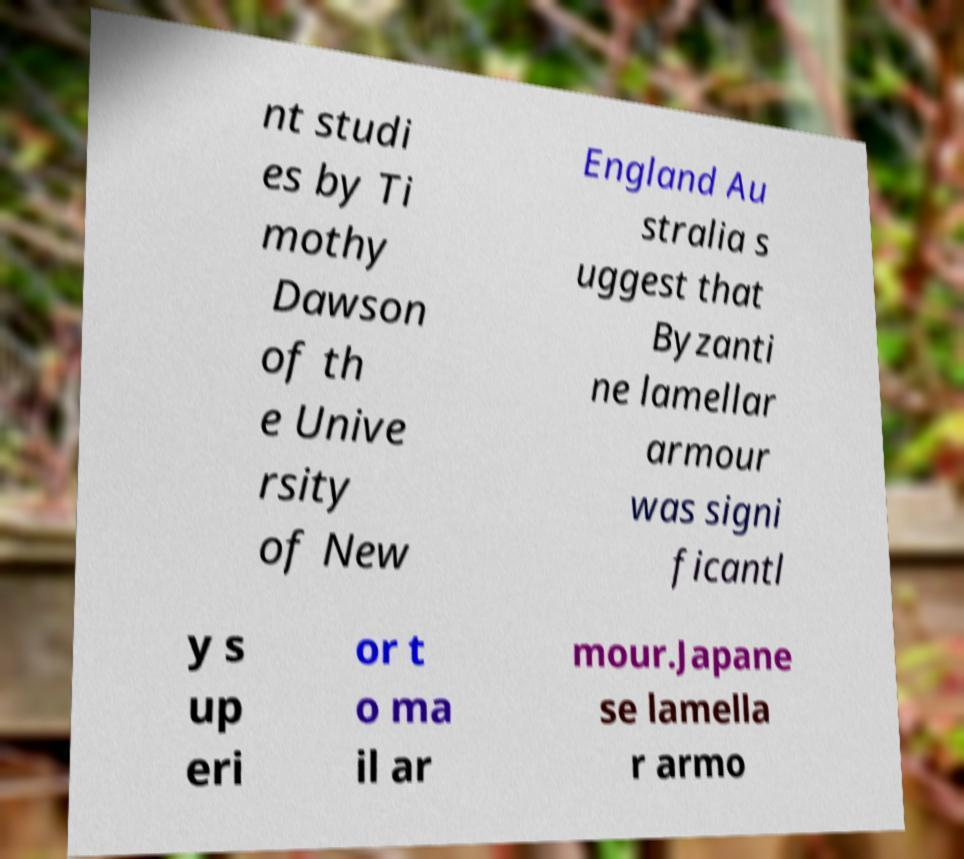Could you extract and type out the text from this image? nt studi es by Ti mothy Dawson of th e Unive rsity of New England Au stralia s uggest that Byzanti ne lamellar armour was signi ficantl y s up eri or t o ma il ar mour.Japane se lamella r armo 